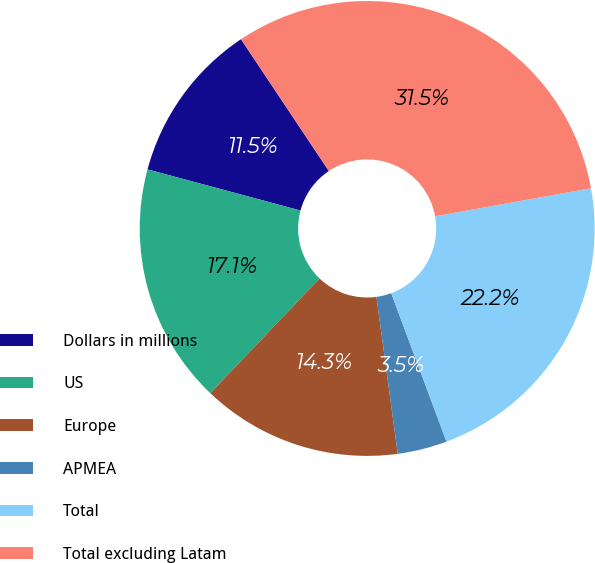Convert chart to OTSL. <chart><loc_0><loc_0><loc_500><loc_500><pie_chart><fcel>Dollars in millions<fcel>US<fcel>Europe<fcel>APMEA<fcel>Total<fcel>Total excluding Latam<nl><fcel>11.46%<fcel>17.07%<fcel>14.26%<fcel>3.52%<fcel>22.16%<fcel>31.53%<nl></chart> 